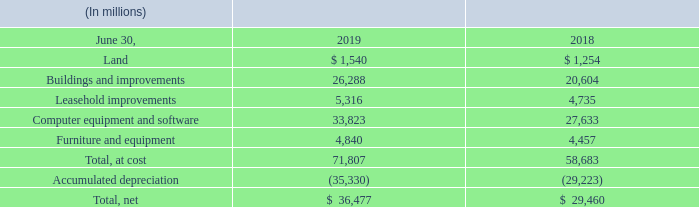NOTE 7 — PROPERTY AND EQUIPMENT
The components of property and equipment were as follows:
During fiscal years 2019, 2018, and 2017, depreciation expense was $9.7 billion, $7.7 billion, and $6.1 billion, respectively. We have committed $4.0 billion for the construction of new buildings, building improvements, and leasehold improvements as of June 30, 2019.
What does note 7 describe? Property and equipment. How much was the depreciation expense for fiscal year 2017? $6.1 billion. How much has the company committed for the construction of new buildings, building improvements, and leasehold improvements? $4.0 billion. How many components of property and equipment are there? Lease##buildings and improvements##leasehold improvements##computer equipment and software##furniture and equipment
Answer: 5. How much was the average depreciation expense over the 3 year period from 2017 to 2019?
Answer scale should be: billion. ($9.7+7.7+6.1)/(2019-2017+1)
Answer: 7.83. How much were the top 3 components of property and equipment as a % of the total at cost, property and equipment for 2019?
Answer scale should be: percent. (26,288+33,823+5,316)/71,807
Answer: 91.12. 